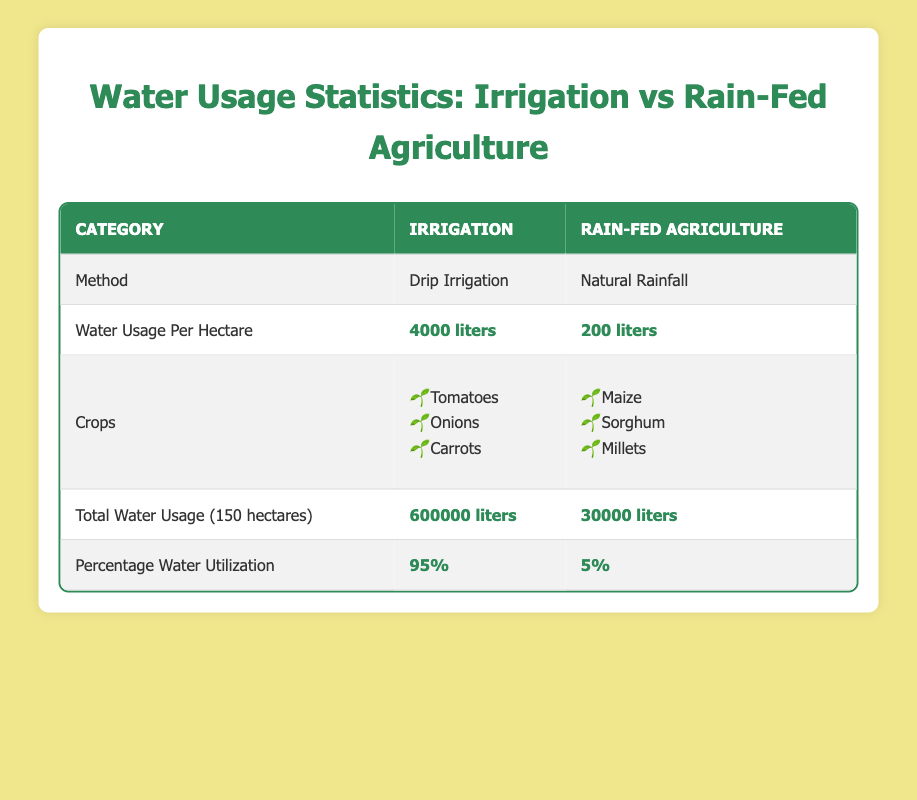What is the water usage per hectare for irrigation? The table indicates that the water usage per hectare for irrigation is specifically listed as 4000 liters.
Answer: 4000 liters What crops are grown using drip irrigation? The table provides a list of crops grown under irrigation with drip irrigation, which includes tomatoes, onions, and carrots.
Answer: Tomatoes, onions, carrots Is the total water usage for rain-fed agriculture greater than that for irrigation? By comparing the total water usage, it is noted that rain-fed agriculture uses 30000 liters, while irrigation uses 600000 liters, making the statement false.
Answer: No What is the total water usage for irrigation over 150 hectares? The table states that the total water usage for irrigation across 150 hectares amounts to 600000 liters.
Answer: 600000 liters Calculate the difference in water usage per hectare between irrigation and rain-fed agriculture. The water usage for irrigation is 4000 liters per hectare, and for rain-fed agriculture, it is 200 liters per hectare. The difference is calculated as 4000 - 200 = 3800 liters.
Answer: 3800 liters What percentage of water usage is attributed to rain-fed agriculture? The table shows that the percentage of water utilization for rain-fed agriculture is 5%.
Answer: 5% Which agricultural method utilizes more water overall? By analyzing the total water usage figures of 600000 liters for irrigation and 30000 liters for rain-fed agriculture, it's clear that irrigation uses significantly more water.
Answer: Irrigation How many crops are associated with each agricultural method? The table shows that there are three crops associated with irrigation (tomatoes, onions, carrots) and three crops for rain-fed agriculture (maize, sorghum, millets), thus both methods have the same number of crops.
Answer: Three crops for each method What is the percentage of water utilization for irrigated agriculture? The table indicates that the percentage of water utilization for irrigated agriculture is 95%.
Answer: 95% 